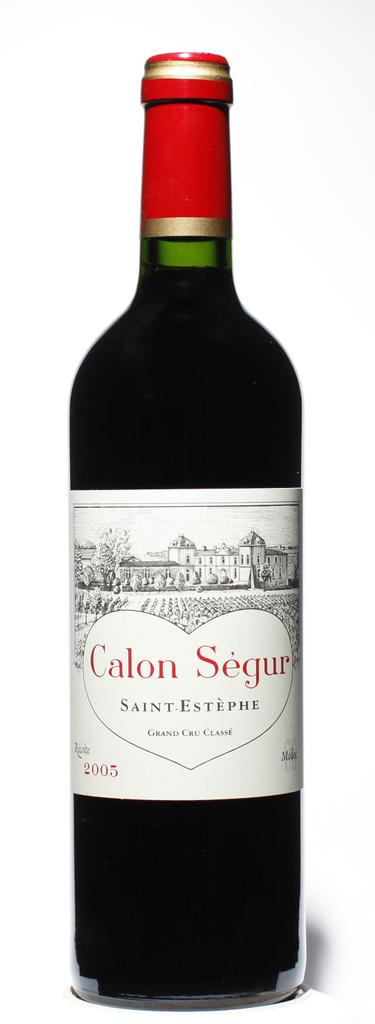Provide a one-sentence caption for the provided image. The bottle of Saint-Estephe Calon Segur Grand Cru Classe is dated 2005. 